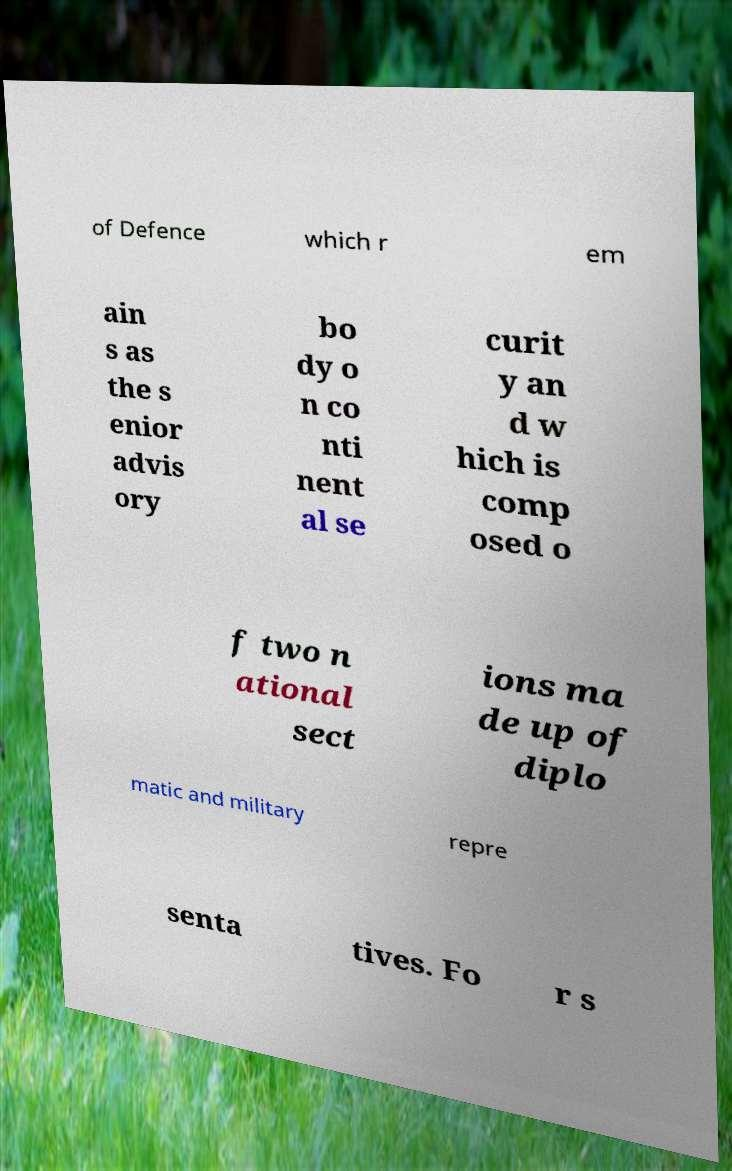Could you extract and type out the text from this image? of Defence which r em ain s as the s enior advis ory bo dy o n co nti nent al se curit y an d w hich is comp osed o f two n ational sect ions ma de up of diplo matic and military repre senta tives. Fo r s 